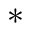<formula> <loc_0><loc_0><loc_500><loc_500>^ { \ast }</formula> 